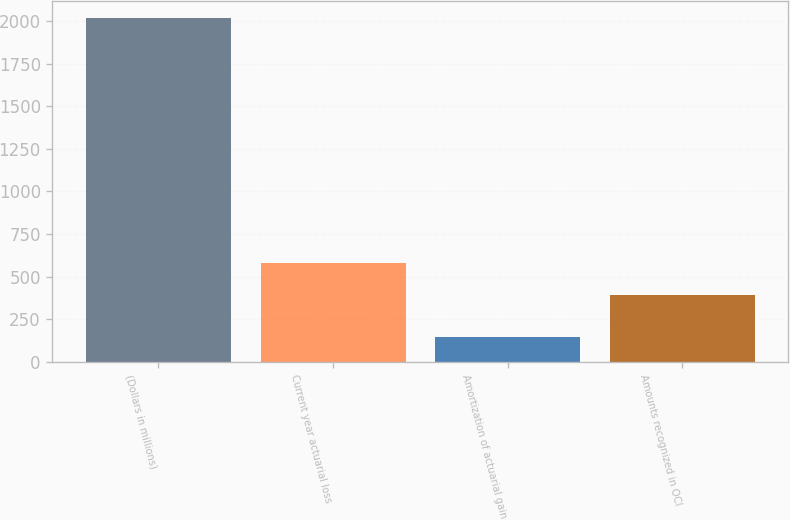Convert chart. <chart><loc_0><loc_0><loc_500><loc_500><bar_chart><fcel>(Dollars in millions)<fcel>Current year actuarial loss<fcel>Amortization of actuarial gain<fcel>Amounts recognized in OCI<nl><fcel>2018<fcel>581.1<fcel>147<fcel>394<nl></chart> 